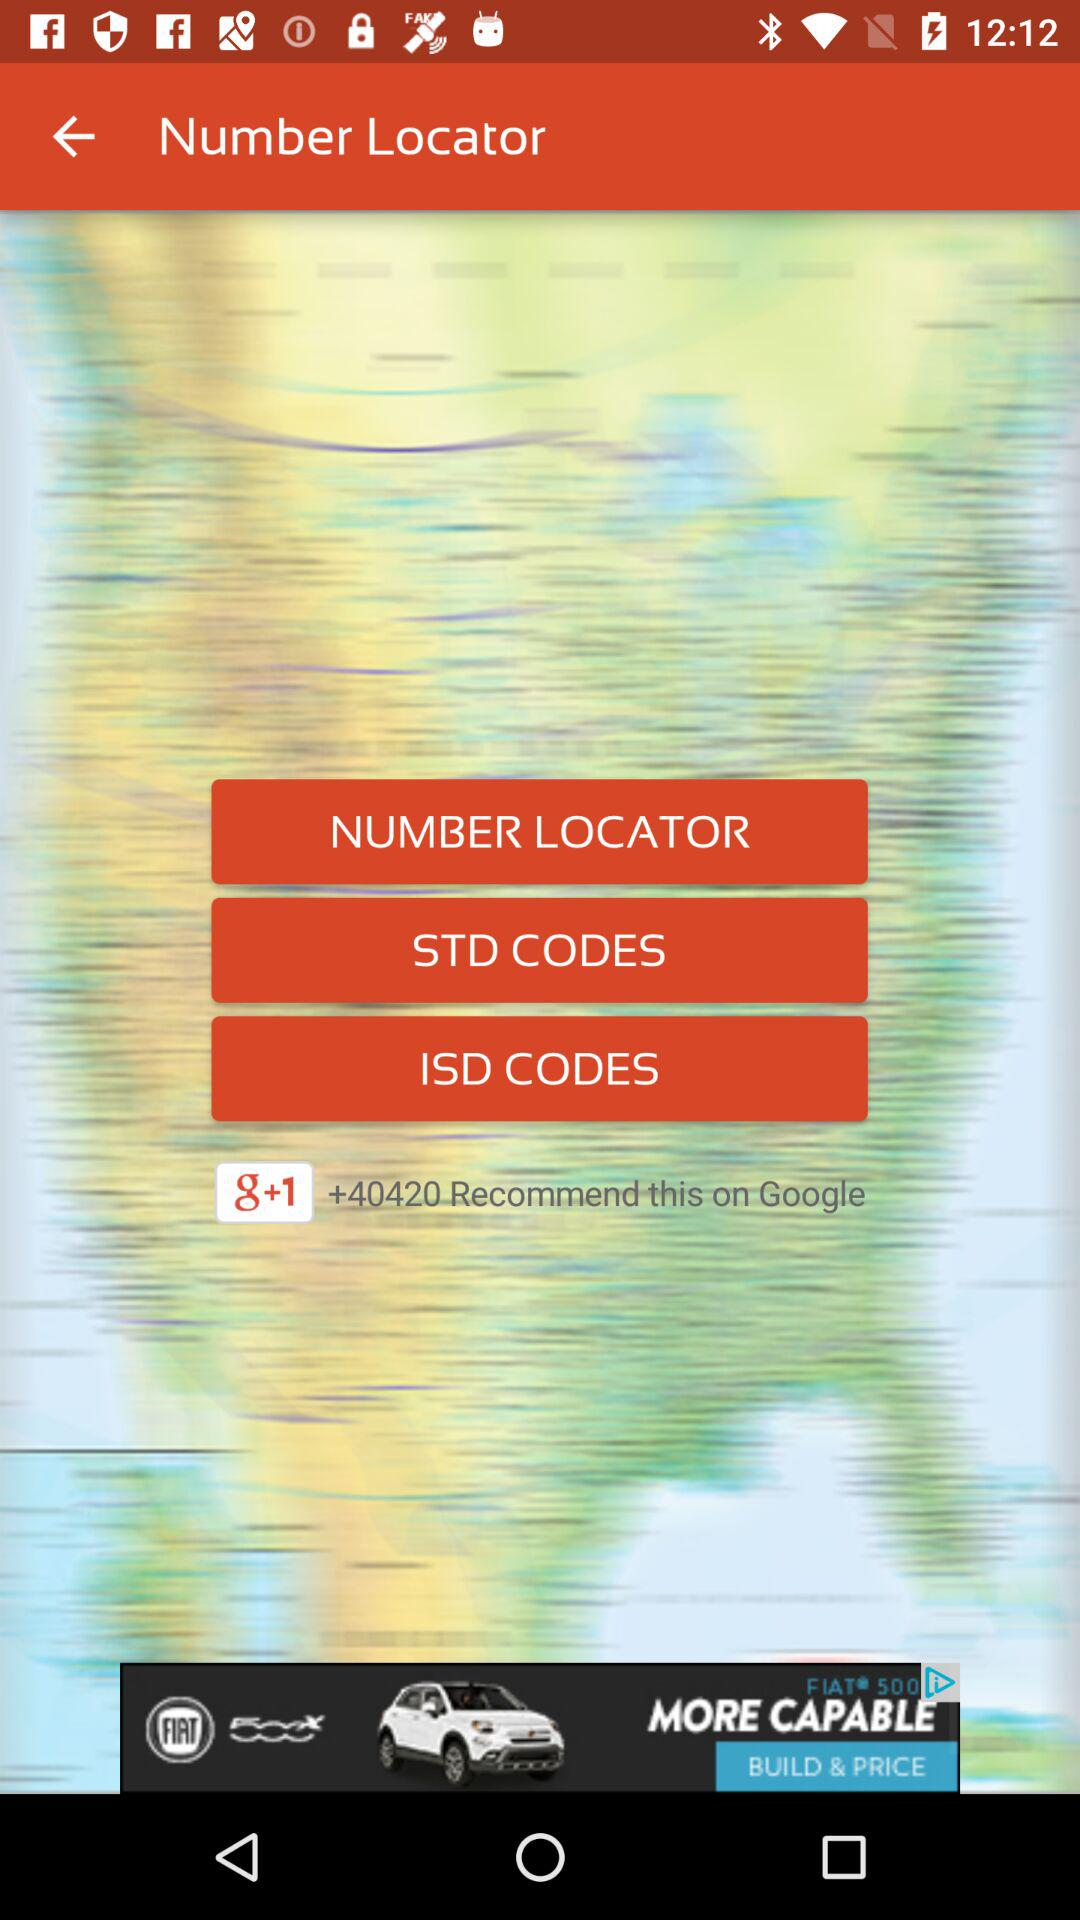How many people have recommended the application on "Google"? The application has been recommended by more than 40,420 people on "Google". 